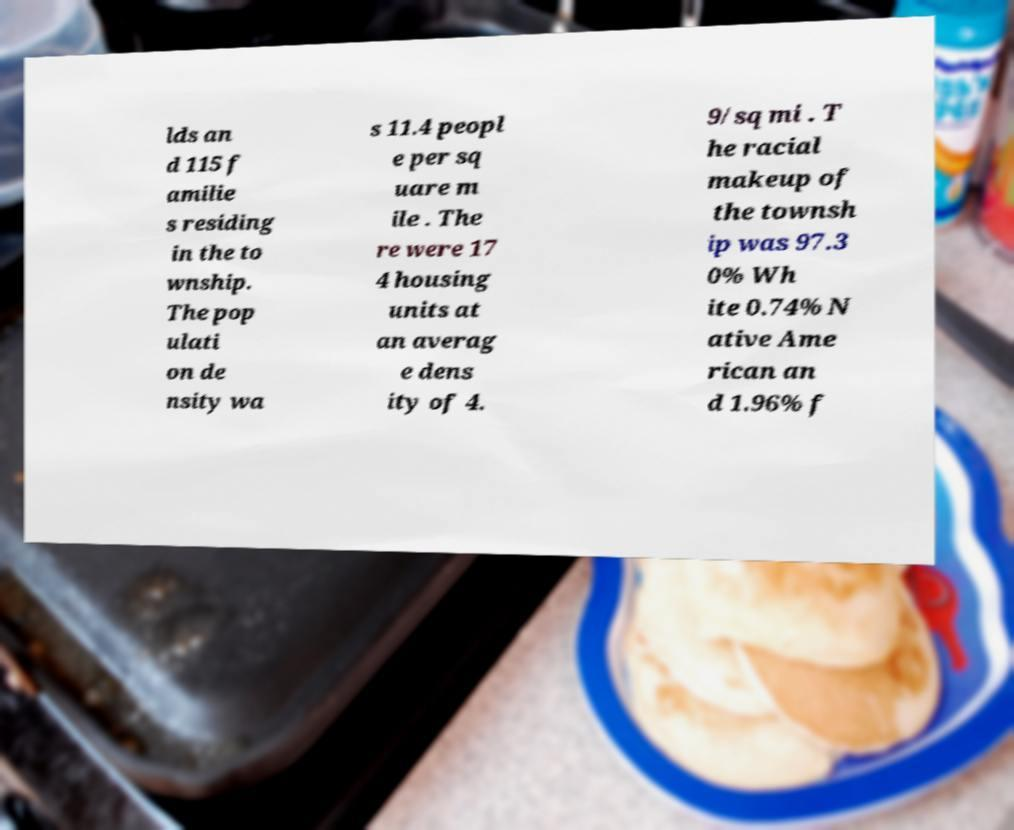I need the written content from this picture converted into text. Can you do that? lds an d 115 f amilie s residing in the to wnship. The pop ulati on de nsity wa s 11.4 peopl e per sq uare m ile . The re were 17 4 housing units at an averag e dens ity of 4. 9/sq mi . T he racial makeup of the townsh ip was 97.3 0% Wh ite 0.74% N ative Ame rican an d 1.96% f 